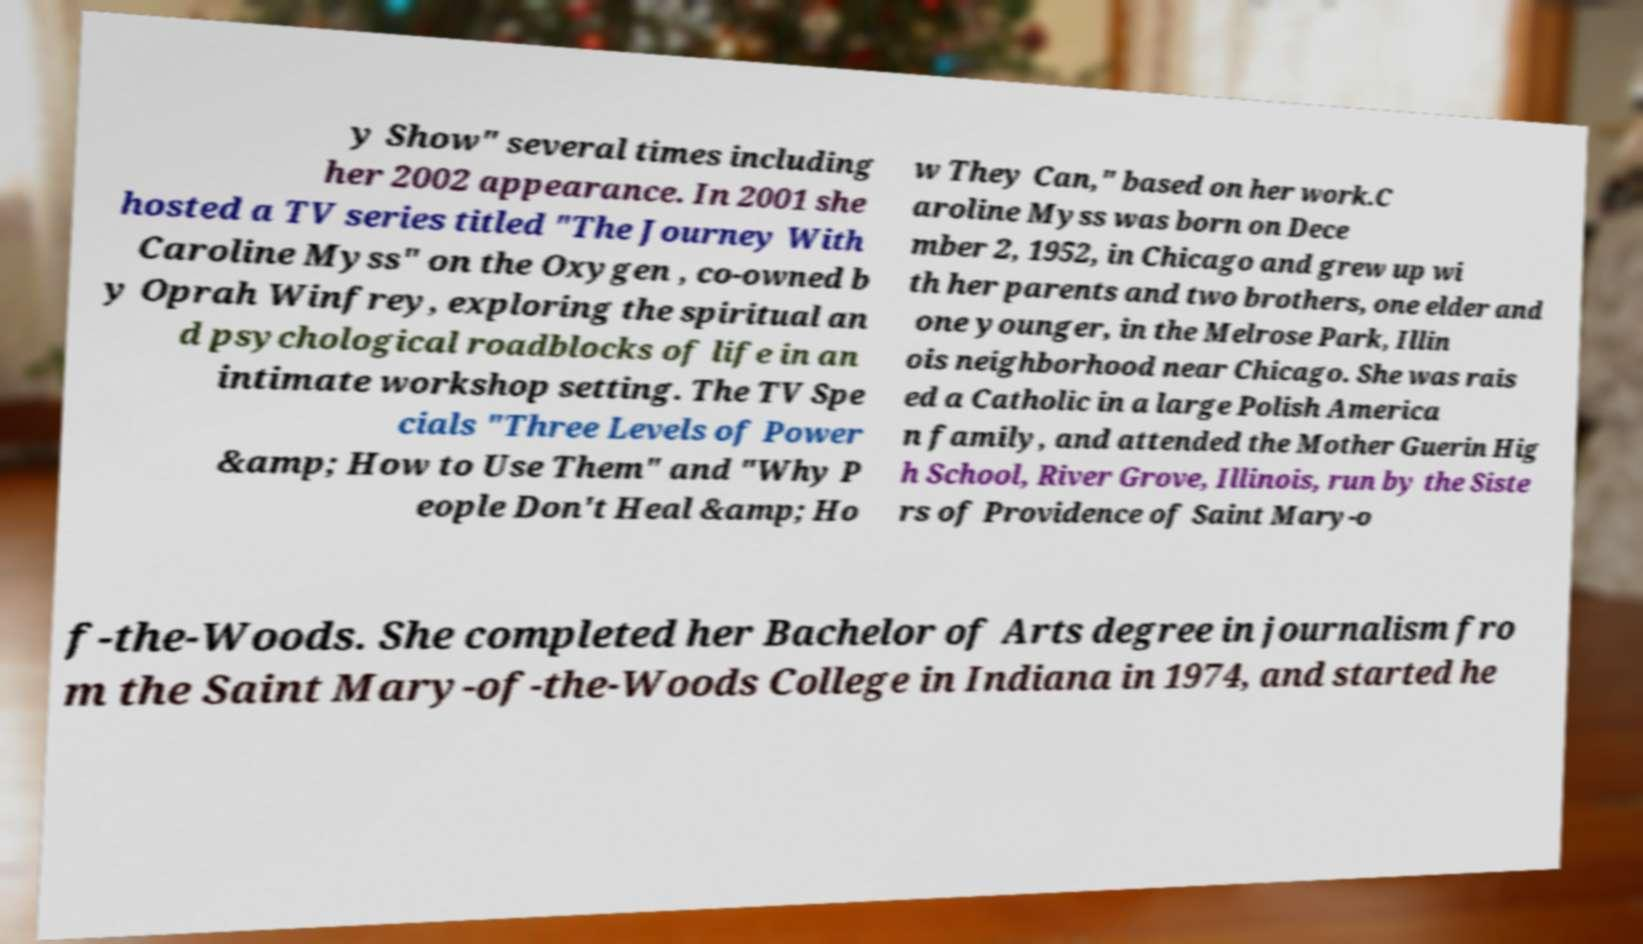Could you assist in decoding the text presented in this image and type it out clearly? y Show" several times including her 2002 appearance. In 2001 she hosted a TV series titled "The Journey With Caroline Myss" on the Oxygen , co-owned b y Oprah Winfrey, exploring the spiritual an d psychological roadblocks of life in an intimate workshop setting. The TV Spe cials "Three Levels of Power &amp; How to Use Them" and "Why P eople Don't Heal &amp; Ho w They Can," based on her work.C aroline Myss was born on Dece mber 2, 1952, in Chicago and grew up wi th her parents and two brothers, one elder and one younger, in the Melrose Park, Illin ois neighborhood near Chicago. She was rais ed a Catholic in a large Polish America n family, and attended the Mother Guerin Hig h School, River Grove, Illinois, run by the Siste rs of Providence of Saint Mary-o f-the-Woods. She completed her Bachelor of Arts degree in journalism fro m the Saint Mary-of-the-Woods College in Indiana in 1974, and started he 